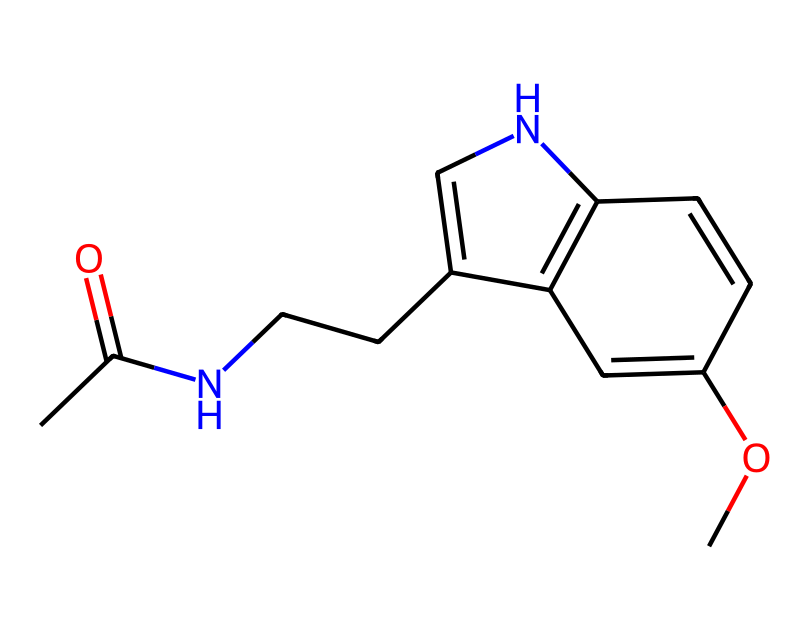What is the molecular formula of melatonin? To determine the molecular formula, count the carbon (C), hydrogen (H), nitrogen (N), and oxygen (O) atoms in the SMILES representation. There are 13 carbon atoms, 16 hydrogen atoms, 2 nitrogen atoms, and 1 oxygen atom, giving the molecular formula C13H16N2O.
Answer: C13H16N2O How many rings are present in the structure? Analyze the rings in the chemical structure by looking for closed loops. The structure contains two distinct ring systems, so the total number of rings is two.
Answer: 2 What is the primary functional group found in melatonin? Examining the structure, the presence of the acetamide group (CC(=O)N) suggests that the primary functional group is an amide. This is confirmed by the nitrogen atom bonded to a carbonyl (C=O).
Answer: amide What is the total number of nitrogen atoms in melatonin? By observing the structure, we can count the nitrogen atoms. There are two nitrogen atoms present in the molecule, visible in the acetamide group and within the rings.
Answer: 2 What characteristic does the methoxy group provide to the structure? The methoxy group (OC) contributes to the overall polarity and solubility of the molecule, affecting its interaction with receptors in the body.
Answer: polarity What role does melatonin play in the body? Melatonin is primarily known for its role in the regulation of sleep cycles and circadian rhythms, which is central to maintaining sleep-wake patterns.
Answer: sleep regulation 